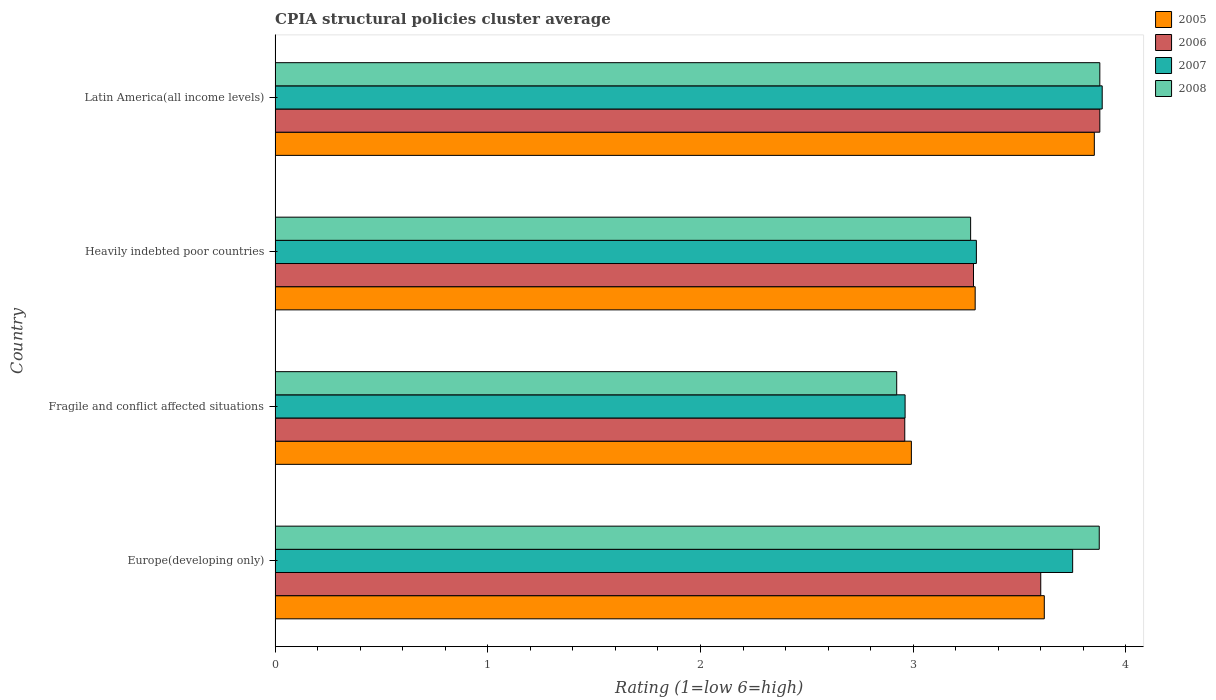How many different coloured bars are there?
Your answer should be compact. 4. How many groups of bars are there?
Offer a very short reply. 4. Are the number of bars on each tick of the Y-axis equal?
Make the answer very short. Yes. What is the label of the 1st group of bars from the top?
Make the answer very short. Latin America(all income levels). In how many cases, is the number of bars for a given country not equal to the number of legend labels?
Make the answer very short. 0. What is the CPIA rating in 2008 in Europe(developing only)?
Give a very brief answer. 3.88. Across all countries, what is the maximum CPIA rating in 2007?
Offer a very short reply. 3.89. Across all countries, what is the minimum CPIA rating in 2005?
Your answer should be compact. 2.99. In which country was the CPIA rating in 2007 maximum?
Make the answer very short. Latin America(all income levels). In which country was the CPIA rating in 2007 minimum?
Make the answer very short. Fragile and conflict affected situations. What is the total CPIA rating in 2007 in the graph?
Offer a very short reply. 13.9. What is the difference between the CPIA rating in 2008 in Heavily indebted poor countries and the CPIA rating in 2005 in Fragile and conflict affected situations?
Keep it short and to the point. 0.28. What is the average CPIA rating in 2005 per country?
Provide a short and direct response. 3.44. What is the difference between the CPIA rating in 2007 and CPIA rating in 2005 in Latin America(all income levels)?
Provide a succinct answer. 0.04. What is the ratio of the CPIA rating in 2005 in Europe(developing only) to that in Heavily indebted poor countries?
Give a very brief answer. 1.1. Is the CPIA rating in 2008 in Europe(developing only) less than that in Heavily indebted poor countries?
Give a very brief answer. No. Is the difference between the CPIA rating in 2007 in Fragile and conflict affected situations and Latin America(all income levels) greater than the difference between the CPIA rating in 2005 in Fragile and conflict affected situations and Latin America(all income levels)?
Make the answer very short. No. What is the difference between the highest and the second highest CPIA rating in 2007?
Give a very brief answer. 0.14. What is the difference between the highest and the lowest CPIA rating in 2007?
Make the answer very short. 0.93. In how many countries, is the CPIA rating in 2008 greater than the average CPIA rating in 2008 taken over all countries?
Offer a very short reply. 2. Is the sum of the CPIA rating in 2007 in Europe(developing only) and Latin America(all income levels) greater than the maximum CPIA rating in 2005 across all countries?
Offer a very short reply. Yes. Is it the case that in every country, the sum of the CPIA rating in 2005 and CPIA rating in 2007 is greater than the sum of CPIA rating in 2006 and CPIA rating in 2008?
Offer a terse response. No. What does the 3rd bar from the top in Europe(developing only) represents?
Give a very brief answer. 2006. Is it the case that in every country, the sum of the CPIA rating in 2006 and CPIA rating in 2008 is greater than the CPIA rating in 2005?
Your answer should be very brief. Yes. How many countries are there in the graph?
Offer a terse response. 4. What is the difference between two consecutive major ticks on the X-axis?
Your answer should be very brief. 1. Are the values on the major ticks of X-axis written in scientific E-notation?
Give a very brief answer. No. Does the graph contain any zero values?
Provide a short and direct response. No. Where does the legend appear in the graph?
Offer a terse response. Top right. How are the legend labels stacked?
Ensure brevity in your answer.  Vertical. What is the title of the graph?
Give a very brief answer. CPIA structural policies cluster average. What is the label or title of the Y-axis?
Provide a succinct answer. Country. What is the Rating (1=low 6=high) of 2005 in Europe(developing only)?
Provide a succinct answer. 3.62. What is the Rating (1=low 6=high) of 2007 in Europe(developing only)?
Offer a terse response. 3.75. What is the Rating (1=low 6=high) in 2008 in Europe(developing only)?
Provide a short and direct response. 3.88. What is the Rating (1=low 6=high) of 2005 in Fragile and conflict affected situations?
Make the answer very short. 2.99. What is the Rating (1=low 6=high) of 2006 in Fragile and conflict affected situations?
Provide a short and direct response. 2.96. What is the Rating (1=low 6=high) of 2007 in Fragile and conflict affected situations?
Ensure brevity in your answer.  2.96. What is the Rating (1=low 6=high) in 2008 in Fragile and conflict affected situations?
Offer a very short reply. 2.92. What is the Rating (1=low 6=high) in 2005 in Heavily indebted poor countries?
Offer a very short reply. 3.29. What is the Rating (1=low 6=high) in 2006 in Heavily indebted poor countries?
Make the answer very short. 3.28. What is the Rating (1=low 6=high) of 2007 in Heavily indebted poor countries?
Provide a succinct answer. 3.3. What is the Rating (1=low 6=high) in 2008 in Heavily indebted poor countries?
Provide a short and direct response. 3.27. What is the Rating (1=low 6=high) of 2005 in Latin America(all income levels)?
Offer a terse response. 3.85. What is the Rating (1=low 6=high) in 2006 in Latin America(all income levels)?
Keep it short and to the point. 3.88. What is the Rating (1=low 6=high) of 2007 in Latin America(all income levels)?
Make the answer very short. 3.89. What is the Rating (1=low 6=high) of 2008 in Latin America(all income levels)?
Your response must be concise. 3.88. Across all countries, what is the maximum Rating (1=low 6=high) in 2005?
Offer a very short reply. 3.85. Across all countries, what is the maximum Rating (1=low 6=high) in 2006?
Provide a short and direct response. 3.88. Across all countries, what is the maximum Rating (1=low 6=high) in 2007?
Give a very brief answer. 3.89. Across all countries, what is the maximum Rating (1=low 6=high) in 2008?
Ensure brevity in your answer.  3.88. Across all countries, what is the minimum Rating (1=low 6=high) of 2005?
Ensure brevity in your answer.  2.99. Across all countries, what is the minimum Rating (1=low 6=high) in 2006?
Offer a terse response. 2.96. Across all countries, what is the minimum Rating (1=low 6=high) of 2007?
Make the answer very short. 2.96. Across all countries, what is the minimum Rating (1=low 6=high) in 2008?
Ensure brevity in your answer.  2.92. What is the total Rating (1=low 6=high) of 2005 in the graph?
Provide a short and direct response. 13.75. What is the total Rating (1=low 6=high) of 2006 in the graph?
Provide a succinct answer. 13.72. What is the total Rating (1=low 6=high) in 2007 in the graph?
Your answer should be compact. 13.9. What is the total Rating (1=low 6=high) in 2008 in the graph?
Offer a terse response. 13.95. What is the difference between the Rating (1=low 6=high) in 2005 in Europe(developing only) and that in Fragile and conflict affected situations?
Your answer should be very brief. 0.62. What is the difference between the Rating (1=low 6=high) of 2006 in Europe(developing only) and that in Fragile and conflict affected situations?
Offer a terse response. 0.64. What is the difference between the Rating (1=low 6=high) of 2007 in Europe(developing only) and that in Fragile and conflict affected situations?
Offer a terse response. 0.79. What is the difference between the Rating (1=low 6=high) of 2008 in Europe(developing only) and that in Fragile and conflict affected situations?
Give a very brief answer. 0.95. What is the difference between the Rating (1=low 6=high) in 2005 in Europe(developing only) and that in Heavily indebted poor countries?
Make the answer very short. 0.33. What is the difference between the Rating (1=low 6=high) in 2006 in Europe(developing only) and that in Heavily indebted poor countries?
Offer a very short reply. 0.32. What is the difference between the Rating (1=low 6=high) in 2007 in Europe(developing only) and that in Heavily indebted poor countries?
Ensure brevity in your answer.  0.45. What is the difference between the Rating (1=low 6=high) in 2008 in Europe(developing only) and that in Heavily indebted poor countries?
Your answer should be very brief. 0.6. What is the difference between the Rating (1=low 6=high) in 2005 in Europe(developing only) and that in Latin America(all income levels)?
Your answer should be very brief. -0.24. What is the difference between the Rating (1=low 6=high) of 2006 in Europe(developing only) and that in Latin America(all income levels)?
Keep it short and to the point. -0.28. What is the difference between the Rating (1=low 6=high) in 2007 in Europe(developing only) and that in Latin America(all income levels)?
Give a very brief answer. -0.14. What is the difference between the Rating (1=low 6=high) of 2008 in Europe(developing only) and that in Latin America(all income levels)?
Provide a succinct answer. -0. What is the difference between the Rating (1=low 6=high) in 2005 in Fragile and conflict affected situations and that in Heavily indebted poor countries?
Your answer should be very brief. -0.3. What is the difference between the Rating (1=low 6=high) in 2006 in Fragile and conflict affected situations and that in Heavily indebted poor countries?
Ensure brevity in your answer.  -0.32. What is the difference between the Rating (1=low 6=high) of 2007 in Fragile and conflict affected situations and that in Heavily indebted poor countries?
Your response must be concise. -0.34. What is the difference between the Rating (1=low 6=high) of 2008 in Fragile and conflict affected situations and that in Heavily indebted poor countries?
Offer a terse response. -0.35. What is the difference between the Rating (1=low 6=high) in 2005 in Fragile and conflict affected situations and that in Latin America(all income levels)?
Offer a terse response. -0.86. What is the difference between the Rating (1=low 6=high) of 2006 in Fragile and conflict affected situations and that in Latin America(all income levels)?
Keep it short and to the point. -0.92. What is the difference between the Rating (1=low 6=high) of 2007 in Fragile and conflict affected situations and that in Latin America(all income levels)?
Ensure brevity in your answer.  -0.93. What is the difference between the Rating (1=low 6=high) of 2008 in Fragile and conflict affected situations and that in Latin America(all income levels)?
Your answer should be very brief. -0.96. What is the difference between the Rating (1=low 6=high) of 2005 in Heavily indebted poor countries and that in Latin America(all income levels)?
Provide a succinct answer. -0.56. What is the difference between the Rating (1=low 6=high) in 2006 in Heavily indebted poor countries and that in Latin America(all income levels)?
Your response must be concise. -0.59. What is the difference between the Rating (1=low 6=high) in 2007 in Heavily indebted poor countries and that in Latin America(all income levels)?
Provide a short and direct response. -0.59. What is the difference between the Rating (1=low 6=high) in 2008 in Heavily indebted poor countries and that in Latin America(all income levels)?
Give a very brief answer. -0.61. What is the difference between the Rating (1=low 6=high) of 2005 in Europe(developing only) and the Rating (1=low 6=high) of 2006 in Fragile and conflict affected situations?
Ensure brevity in your answer.  0.66. What is the difference between the Rating (1=low 6=high) in 2005 in Europe(developing only) and the Rating (1=low 6=high) in 2007 in Fragile and conflict affected situations?
Make the answer very short. 0.65. What is the difference between the Rating (1=low 6=high) of 2005 in Europe(developing only) and the Rating (1=low 6=high) of 2008 in Fragile and conflict affected situations?
Make the answer very short. 0.69. What is the difference between the Rating (1=low 6=high) in 2006 in Europe(developing only) and the Rating (1=low 6=high) in 2007 in Fragile and conflict affected situations?
Make the answer very short. 0.64. What is the difference between the Rating (1=low 6=high) in 2006 in Europe(developing only) and the Rating (1=low 6=high) in 2008 in Fragile and conflict affected situations?
Your answer should be very brief. 0.68. What is the difference between the Rating (1=low 6=high) of 2007 in Europe(developing only) and the Rating (1=low 6=high) of 2008 in Fragile and conflict affected situations?
Give a very brief answer. 0.83. What is the difference between the Rating (1=low 6=high) in 2005 in Europe(developing only) and the Rating (1=low 6=high) in 2006 in Heavily indebted poor countries?
Offer a very short reply. 0.33. What is the difference between the Rating (1=low 6=high) in 2005 in Europe(developing only) and the Rating (1=low 6=high) in 2007 in Heavily indebted poor countries?
Give a very brief answer. 0.32. What is the difference between the Rating (1=low 6=high) of 2005 in Europe(developing only) and the Rating (1=low 6=high) of 2008 in Heavily indebted poor countries?
Give a very brief answer. 0.35. What is the difference between the Rating (1=low 6=high) in 2006 in Europe(developing only) and the Rating (1=low 6=high) in 2007 in Heavily indebted poor countries?
Keep it short and to the point. 0.3. What is the difference between the Rating (1=low 6=high) in 2006 in Europe(developing only) and the Rating (1=low 6=high) in 2008 in Heavily indebted poor countries?
Offer a terse response. 0.33. What is the difference between the Rating (1=low 6=high) of 2007 in Europe(developing only) and the Rating (1=low 6=high) of 2008 in Heavily indebted poor countries?
Give a very brief answer. 0.48. What is the difference between the Rating (1=low 6=high) in 2005 in Europe(developing only) and the Rating (1=low 6=high) in 2006 in Latin America(all income levels)?
Offer a terse response. -0.26. What is the difference between the Rating (1=low 6=high) of 2005 in Europe(developing only) and the Rating (1=low 6=high) of 2007 in Latin America(all income levels)?
Offer a very short reply. -0.27. What is the difference between the Rating (1=low 6=high) in 2005 in Europe(developing only) and the Rating (1=low 6=high) in 2008 in Latin America(all income levels)?
Keep it short and to the point. -0.26. What is the difference between the Rating (1=low 6=high) in 2006 in Europe(developing only) and the Rating (1=low 6=high) in 2007 in Latin America(all income levels)?
Your response must be concise. -0.29. What is the difference between the Rating (1=low 6=high) of 2006 in Europe(developing only) and the Rating (1=low 6=high) of 2008 in Latin America(all income levels)?
Keep it short and to the point. -0.28. What is the difference between the Rating (1=low 6=high) of 2007 in Europe(developing only) and the Rating (1=low 6=high) of 2008 in Latin America(all income levels)?
Give a very brief answer. -0.13. What is the difference between the Rating (1=low 6=high) of 2005 in Fragile and conflict affected situations and the Rating (1=low 6=high) of 2006 in Heavily indebted poor countries?
Offer a very short reply. -0.29. What is the difference between the Rating (1=low 6=high) of 2005 in Fragile and conflict affected situations and the Rating (1=low 6=high) of 2007 in Heavily indebted poor countries?
Give a very brief answer. -0.31. What is the difference between the Rating (1=low 6=high) in 2005 in Fragile and conflict affected situations and the Rating (1=low 6=high) in 2008 in Heavily indebted poor countries?
Provide a short and direct response. -0.28. What is the difference between the Rating (1=low 6=high) of 2006 in Fragile and conflict affected situations and the Rating (1=low 6=high) of 2007 in Heavily indebted poor countries?
Ensure brevity in your answer.  -0.34. What is the difference between the Rating (1=low 6=high) of 2006 in Fragile and conflict affected situations and the Rating (1=low 6=high) of 2008 in Heavily indebted poor countries?
Provide a short and direct response. -0.31. What is the difference between the Rating (1=low 6=high) in 2007 in Fragile and conflict affected situations and the Rating (1=low 6=high) in 2008 in Heavily indebted poor countries?
Provide a succinct answer. -0.31. What is the difference between the Rating (1=low 6=high) in 2005 in Fragile and conflict affected situations and the Rating (1=low 6=high) in 2006 in Latin America(all income levels)?
Ensure brevity in your answer.  -0.89. What is the difference between the Rating (1=low 6=high) of 2005 in Fragile and conflict affected situations and the Rating (1=low 6=high) of 2007 in Latin America(all income levels)?
Keep it short and to the point. -0.9. What is the difference between the Rating (1=low 6=high) in 2005 in Fragile and conflict affected situations and the Rating (1=low 6=high) in 2008 in Latin America(all income levels)?
Your answer should be compact. -0.89. What is the difference between the Rating (1=low 6=high) of 2006 in Fragile and conflict affected situations and the Rating (1=low 6=high) of 2007 in Latin America(all income levels)?
Keep it short and to the point. -0.93. What is the difference between the Rating (1=low 6=high) of 2006 in Fragile and conflict affected situations and the Rating (1=low 6=high) of 2008 in Latin America(all income levels)?
Provide a short and direct response. -0.92. What is the difference between the Rating (1=low 6=high) of 2007 in Fragile and conflict affected situations and the Rating (1=low 6=high) of 2008 in Latin America(all income levels)?
Ensure brevity in your answer.  -0.92. What is the difference between the Rating (1=low 6=high) of 2005 in Heavily indebted poor countries and the Rating (1=low 6=high) of 2006 in Latin America(all income levels)?
Ensure brevity in your answer.  -0.59. What is the difference between the Rating (1=low 6=high) in 2005 in Heavily indebted poor countries and the Rating (1=low 6=high) in 2007 in Latin America(all income levels)?
Provide a succinct answer. -0.6. What is the difference between the Rating (1=low 6=high) in 2005 in Heavily indebted poor countries and the Rating (1=low 6=high) in 2008 in Latin America(all income levels)?
Provide a succinct answer. -0.59. What is the difference between the Rating (1=low 6=high) in 2006 in Heavily indebted poor countries and the Rating (1=low 6=high) in 2007 in Latin America(all income levels)?
Provide a succinct answer. -0.61. What is the difference between the Rating (1=low 6=high) in 2006 in Heavily indebted poor countries and the Rating (1=low 6=high) in 2008 in Latin America(all income levels)?
Offer a very short reply. -0.59. What is the difference between the Rating (1=low 6=high) of 2007 in Heavily indebted poor countries and the Rating (1=low 6=high) of 2008 in Latin America(all income levels)?
Offer a very short reply. -0.58. What is the average Rating (1=low 6=high) of 2005 per country?
Provide a short and direct response. 3.44. What is the average Rating (1=low 6=high) of 2006 per country?
Give a very brief answer. 3.43. What is the average Rating (1=low 6=high) of 2007 per country?
Your answer should be compact. 3.47. What is the average Rating (1=low 6=high) in 2008 per country?
Make the answer very short. 3.49. What is the difference between the Rating (1=low 6=high) of 2005 and Rating (1=low 6=high) of 2006 in Europe(developing only)?
Offer a terse response. 0.02. What is the difference between the Rating (1=low 6=high) in 2005 and Rating (1=low 6=high) in 2007 in Europe(developing only)?
Provide a short and direct response. -0.13. What is the difference between the Rating (1=low 6=high) of 2005 and Rating (1=low 6=high) of 2008 in Europe(developing only)?
Offer a terse response. -0.26. What is the difference between the Rating (1=low 6=high) of 2006 and Rating (1=low 6=high) of 2008 in Europe(developing only)?
Offer a terse response. -0.28. What is the difference between the Rating (1=low 6=high) of 2007 and Rating (1=low 6=high) of 2008 in Europe(developing only)?
Offer a terse response. -0.12. What is the difference between the Rating (1=low 6=high) of 2005 and Rating (1=low 6=high) of 2006 in Fragile and conflict affected situations?
Provide a succinct answer. 0.03. What is the difference between the Rating (1=low 6=high) in 2005 and Rating (1=low 6=high) in 2007 in Fragile and conflict affected situations?
Your answer should be very brief. 0.03. What is the difference between the Rating (1=low 6=high) in 2005 and Rating (1=low 6=high) in 2008 in Fragile and conflict affected situations?
Make the answer very short. 0.07. What is the difference between the Rating (1=low 6=high) in 2006 and Rating (1=low 6=high) in 2007 in Fragile and conflict affected situations?
Offer a terse response. -0. What is the difference between the Rating (1=low 6=high) in 2006 and Rating (1=low 6=high) in 2008 in Fragile and conflict affected situations?
Ensure brevity in your answer.  0.04. What is the difference between the Rating (1=low 6=high) of 2007 and Rating (1=low 6=high) of 2008 in Fragile and conflict affected situations?
Offer a terse response. 0.04. What is the difference between the Rating (1=low 6=high) in 2005 and Rating (1=low 6=high) in 2006 in Heavily indebted poor countries?
Provide a succinct answer. 0.01. What is the difference between the Rating (1=low 6=high) of 2005 and Rating (1=low 6=high) of 2007 in Heavily indebted poor countries?
Ensure brevity in your answer.  -0.01. What is the difference between the Rating (1=low 6=high) in 2005 and Rating (1=low 6=high) in 2008 in Heavily indebted poor countries?
Ensure brevity in your answer.  0.02. What is the difference between the Rating (1=low 6=high) of 2006 and Rating (1=low 6=high) of 2007 in Heavily indebted poor countries?
Give a very brief answer. -0.01. What is the difference between the Rating (1=low 6=high) of 2006 and Rating (1=low 6=high) of 2008 in Heavily indebted poor countries?
Your answer should be compact. 0.01. What is the difference between the Rating (1=low 6=high) of 2007 and Rating (1=low 6=high) of 2008 in Heavily indebted poor countries?
Offer a terse response. 0.03. What is the difference between the Rating (1=low 6=high) in 2005 and Rating (1=low 6=high) in 2006 in Latin America(all income levels)?
Your response must be concise. -0.03. What is the difference between the Rating (1=low 6=high) of 2005 and Rating (1=low 6=high) of 2007 in Latin America(all income levels)?
Provide a short and direct response. -0.04. What is the difference between the Rating (1=low 6=high) in 2005 and Rating (1=low 6=high) in 2008 in Latin America(all income levels)?
Your answer should be compact. -0.03. What is the difference between the Rating (1=low 6=high) of 2006 and Rating (1=low 6=high) of 2007 in Latin America(all income levels)?
Your response must be concise. -0.01. What is the difference between the Rating (1=low 6=high) in 2007 and Rating (1=low 6=high) in 2008 in Latin America(all income levels)?
Offer a terse response. 0.01. What is the ratio of the Rating (1=low 6=high) in 2005 in Europe(developing only) to that in Fragile and conflict affected situations?
Keep it short and to the point. 1.21. What is the ratio of the Rating (1=low 6=high) in 2006 in Europe(developing only) to that in Fragile and conflict affected situations?
Keep it short and to the point. 1.22. What is the ratio of the Rating (1=low 6=high) of 2007 in Europe(developing only) to that in Fragile and conflict affected situations?
Keep it short and to the point. 1.27. What is the ratio of the Rating (1=low 6=high) of 2008 in Europe(developing only) to that in Fragile and conflict affected situations?
Your response must be concise. 1.33. What is the ratio of the Rating (1=low 6=high) of 2005 in Europe(developing only) to that in Heavily indebted poor countries?
Offer a very short reply. 1.1. What is the ratio of the Rating (1=low 6=high) in 2006 in Europe(developing only) to that in Heavily indebted poor countries?
Offer a very short reply. 1.1. What is the ratio of the Rating (1=low 6=high) in 2007 in Europe(developing only) to that in Heavily indebted poor countries?
Keep it short and to the point. 1.14. What is the ratio of the Rating (1=low 6=high) of 2008 in Europe(developing only) to that in Heavily indebted poor countries?
Make the answer very short. 1.18. What is the ratio of the Rating (1=low 6=high) in 2005 in Europe(developing only) to that in Latin America(all income levels)?
Ensure brevity in your answer.  0.94. What is the ratio of the Rating (1=low 6=high) in 2006 in Europe(developing only) to that in Latin America(all income levels)?
Offer a terse response. 0.93. What is the ratio of the Rating (1=low 6=high) in 2005 in Fragile and conflict affected situations to that in Heavily indebted poor countries?
Make the answer very short. 0.91. What is the ratio of the Rating (1=low 6=high) in 2006 in Fragile and conflict affected situations to that in Heavily indebted poor countries?
Provide a succinct answer. 0.9. What is the ratio of the Rating (1=low 6=high) in 2007 in Fragile and conflict affected situations to that in Heavily indebted poor countries?
Offer a terse response. 0.9. What is the ratio of the Rating (1=low 6=high) of 2008 in Fragile and conflict affected situations to that in Heavily indebted poor countries?
Make the answer very short. 0.89. What is the ratio of the Rating (1=low 6=high) in 2005 in Fragile and conflict affected situations to that in Latin America(all income levels)?
Your response must be concise. 0.78. What is the ratio of the Rating (1=low 6=high) of 2006 in Fragile and conflict affected situations to that in Latin America(all income levels)?
Offer a very short reply. 0.76. What is the ratio of the Rating (1=low 6=high) of 2007 in Fragile and conflict affected situations to that in Latin America(all income levels)?
Provide a succinct answer. 0.76. What is the ratio of the Rating (1=low 6=high) of 2008 in Fragile and conflict affected situations to that in Latin America(all income levels)?
Give a very brief answer. 0.75. What is the ratio of the Rating (1=low 6=high) in 2005 in Heavily indebted poor countries to that in Latin America(all income levels)?
Offer a very short reply. 0.85. What is the ratio of the Rating (1=low 6=high) in 2006 in Heavily indebted poor countries to that in Latin America(all income levels)?
Ensure brevity in your answer.  0.85. What is the ratio of the Rating (1=low 6=high) of 2007 in Heavily indebted poor countries to that in Latin America(all income levels)?
Keep it short and to the point. 0.85. What is the ratio of the Rating (1=low 6=high) in 2008 in Heavily indebted poor countries to that in Latin America(all income levels)?
Give a very brief answer. 0.84. What is the difference between the highest and the second highest Rating (1=low 6=high) in 2005?
Make the answer very short. 0.24. What is the difference between the highest and the second highest Rating (1=low 6=high) of 2006?
Give a very brief answer. 0.28. What is the difference between the highest and the second highest Rating (1=low 6=high) of 2007?
Your answer should be compact. 0.14. What is the difference between the highest and the second highest Rating (1=low 6=high) of 2008?
Keep it short and to the point. 0. What is the difference between the highest and the lowest Rating (1=low 6=high) of 2005?
Your answer should be compact. 0.86. What is the difference between the highest and the lowest Rating (1=low 6=high) of 2006?
Provide a short and direct response. 0.92. What is the difference between the highest and the lowest Rating (1=low 6=high) in 2007?
Your answer should be compact. 0.93. What is the difference between the highest and the lowest Rating (1=low 6=high) in 2008?
Provide a succinct answer. 0.96. 